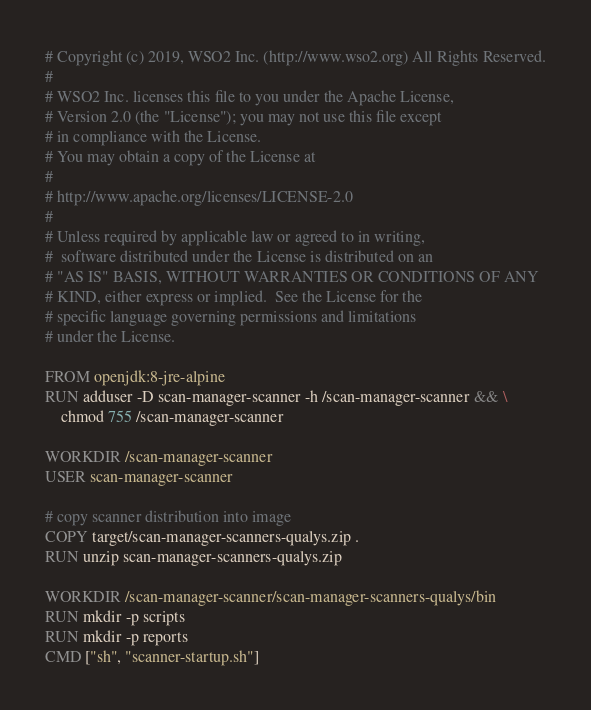<code> <loc_0><loc_0><loc_500><loc_500><_Dockerfile_># Copyright (c) 2019, WSO2 Inc. (http://www.wso2.org) All Rights Reserved.
#
# WSO2 Inc. licenses this file to you under the Apache License,
# Version 2.0 (the "License"); you may not use this file except
# in compliance with the License.
# You may obtain a copy of the License at
#
# http://www.apache.org/licenses/LICENSE-2.0
#
# Unless required by applicable law or agreed to in writing,
#  software distributed under the License is distributed on an
# "AS IS" BASIS, WITHOUT WARRANTIES OR CONDITIONS OF ANY
# KIND, either express or implied.  See the License for the
# specific language governing permissions and limitations
# under the License.

FROM openjdk:8-jre-alpine
RUN adduser -D scan-manager-scanner -h /scan-manager-scanner && \
    chmod 755 /scan-manager-scanner

WORKDIR /scan-manager-scanner
USER scan-manager-scanner

# copy scanner distribution into image
COPY target/scan-manager-scanners-qualys.zip .
RUN unzip scan-manager-scanners-qualys.zip

WORKDIR /scan-manager-scanner/scan-manager-scanners-qualys/bin
RUN mkdir -p scripts
RUN mkdir -p reports
CMD ["sh", "scanner-startup.sh"]
</code> 